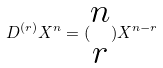Convert formula to latex. <formula><loc_0><loc_0><loc_500><loc_500>D ^ { ( r ) } X ^ { n } = ( \begin{matrix} n \\ r \end{matrix} ) X ^ { n - r }</formula> 